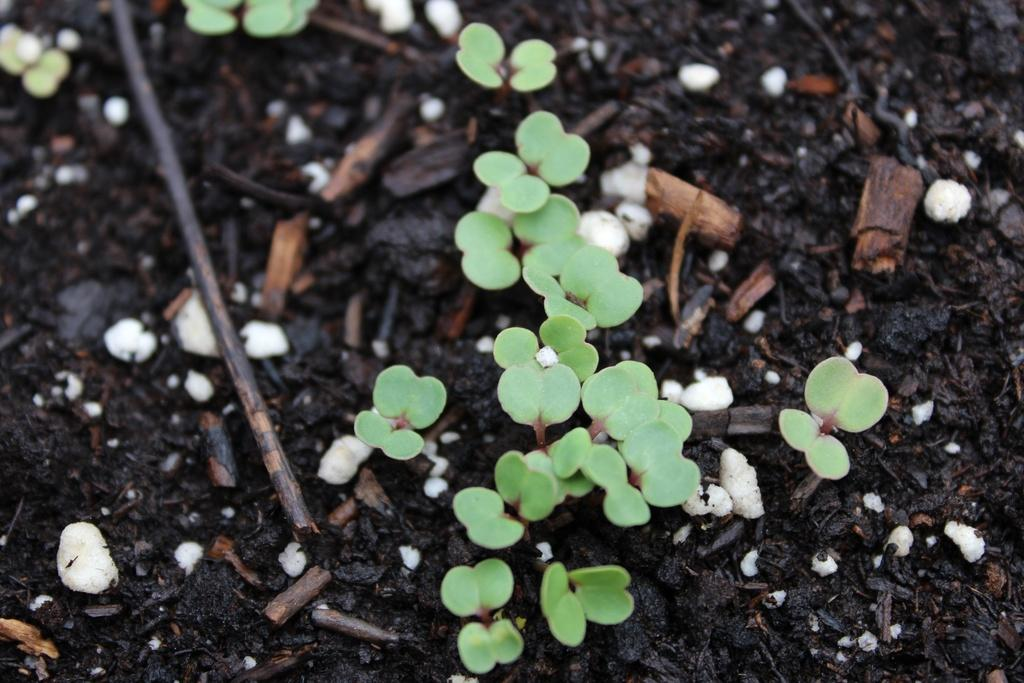What type of plants are in the image? There are small plants in the image. Where are the small plants located? The small plants are on the ground. Can you describe the position of the small plants in the image? The small plants are in the middle of the image. Reasoning: Let'g: Let's think step by step in order to produce the conversation. We start by identifying the main subject in the image, which are the small plants. Then, we describe their location and position within the image. Each question is designed to elicit a specific detail about the image that is known from the provided facts. Absurd Question/Answer: How many girls are standing on the small plants in the image? There are no girls present in the image, only small plants. What type of home is visible in the image? There is no home visible in the image; it only features small plants on the ground. Are the small plants using their feet to hold the home in the image? There is no home visible in the image, and the small plants do not have feet. 